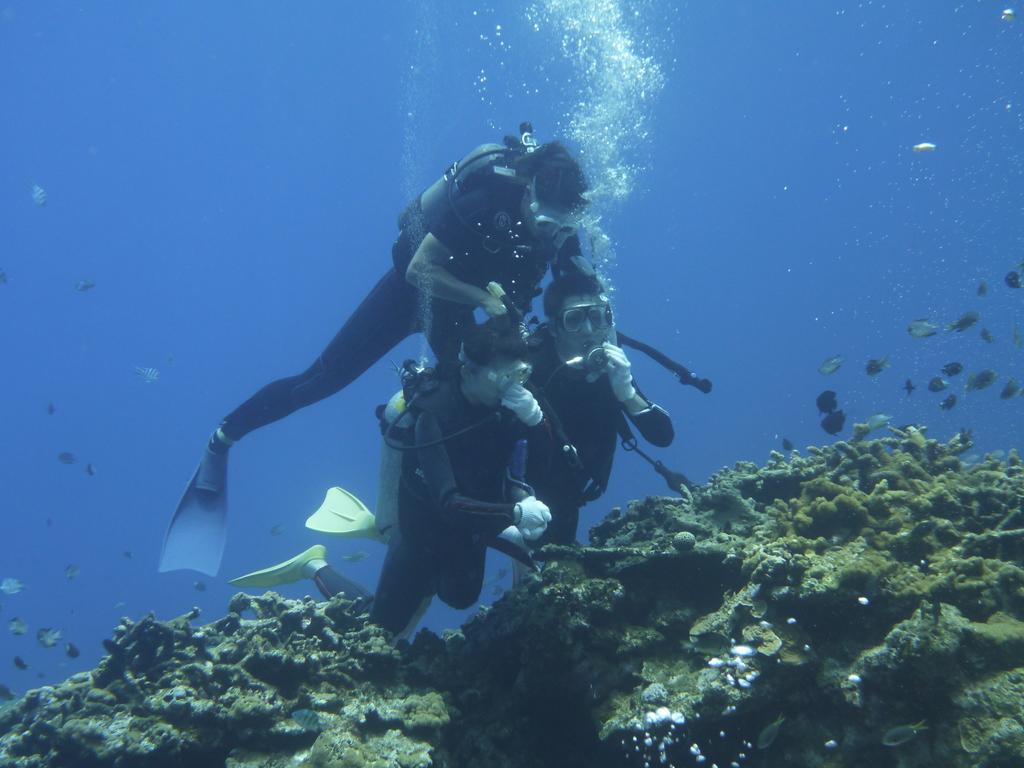What are the people in the image doing? The people in the image are swimming in the water. What else can be seen in the water besides the people? Fishes are visible in the image. What type of fruit is being smashed by the maid in the image? There is no maid or fruit present in the image; it features people swimming and fishes in the water. 